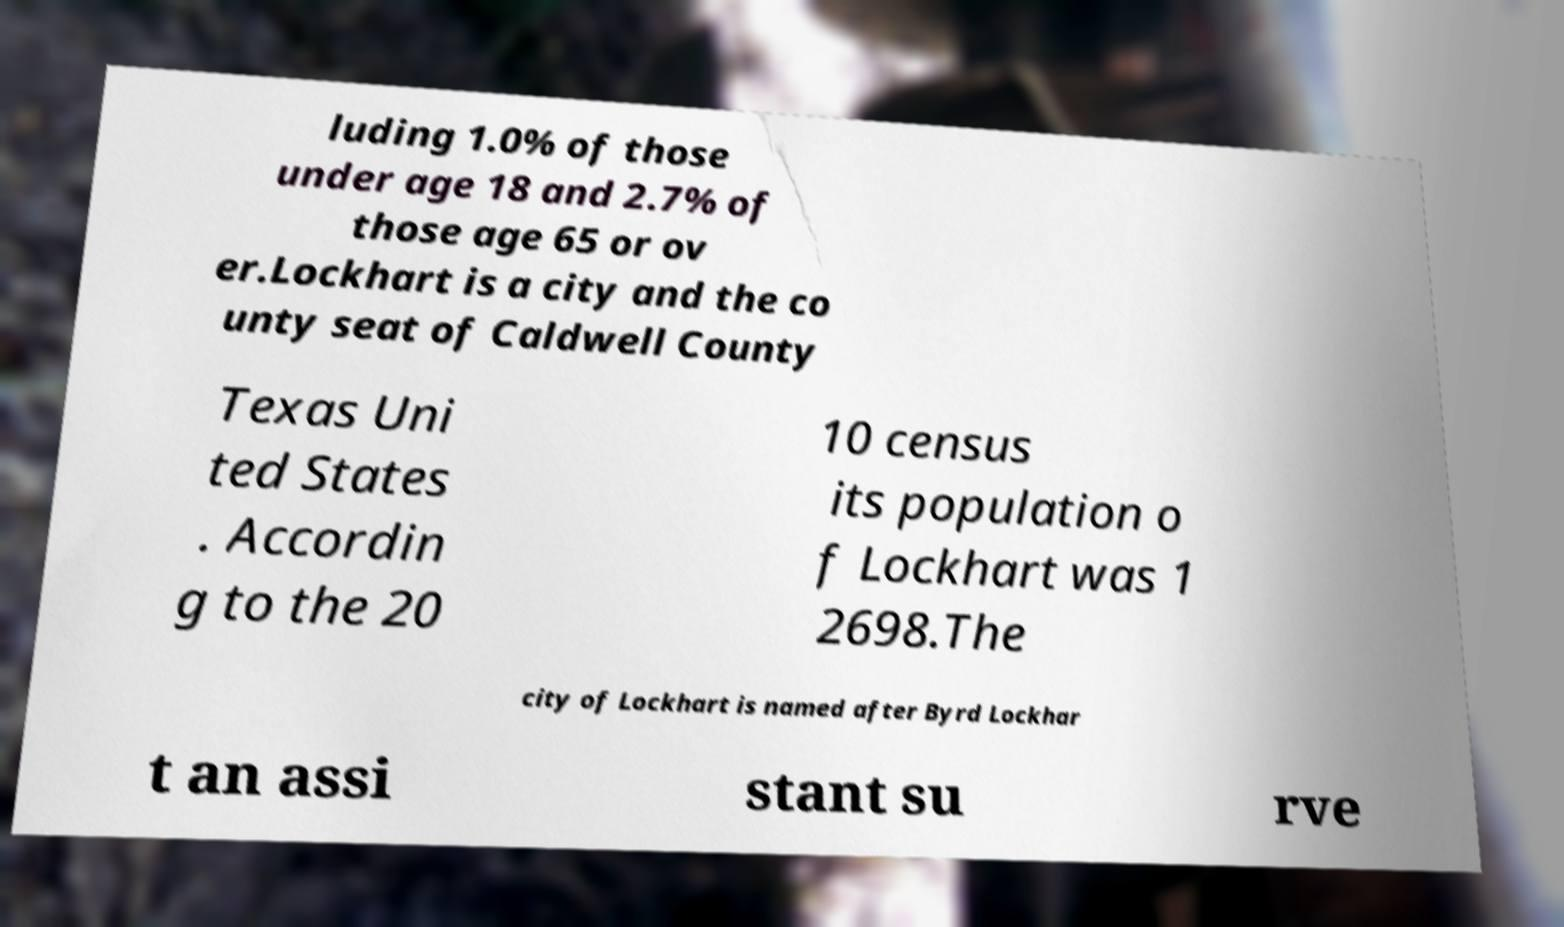What messages or text are displayed in this image? I need them in a readable, typed format. luding 1.0% of those under age 18 and 2.7% of those age 65 or ov er.Lockhart is a city and the co unty seat of Caldwell County Texas Uni ted States . Accordin g to the 20 10 census its population o f Lockhart was 1 2698.The city of Lockhart is named after Byrd Lockhar t an assi stant su rve 